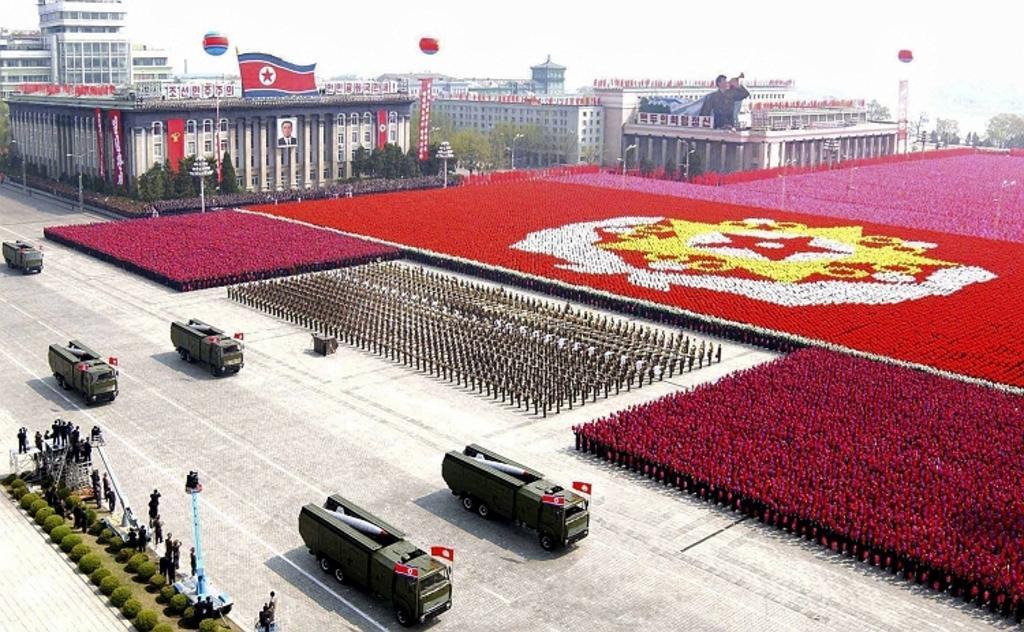Describe this image in one or two sentences. In the foreground I can see plants, poles, group of people, trucks on the road and a crowd on the ground. In the background I can see buildings, fence, trees and the sky. This image is taken during a day on the ground. 